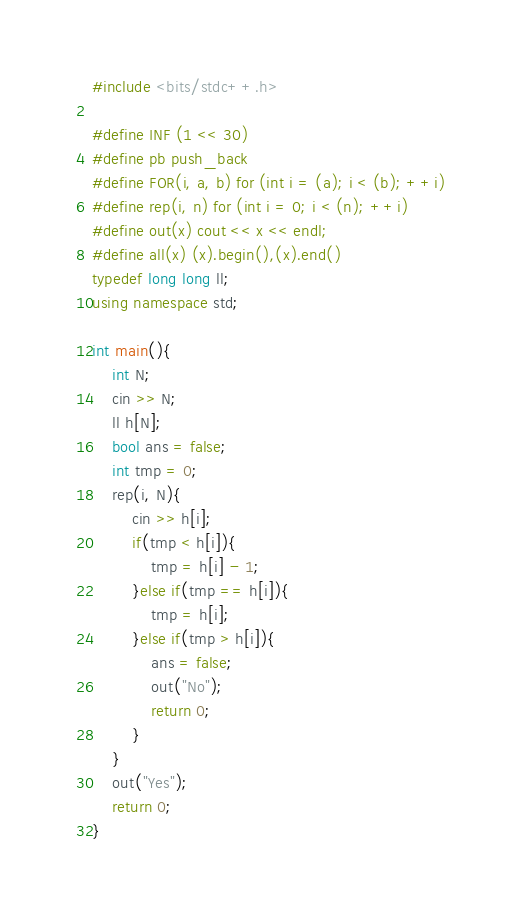<code> <loc_0><loc_0><loc_500><loc_500><_C++_>#include <bits/stdc++.h>

#define INF (1 << 30)
#define pb push_back
#define FOR(i, a, b) for (int i = (a); i < (b); ++i)
#define rep(i, n) for (int i = 0; i < (n); ++i)
#define out(x) cout << x << endl;
#define all(x) (x).begin(),(x).end()
typedef long long ll;
using namespace std;

int main(){
    int N;
    cin >> N;
    ll h[N];
    bool ans = false;
    int tmp = 0;
    rep(i, N){
        cin >> h[i];
        if(tmp < h[i]){
            tmp = h[i] - 1;
        }else if(tmp == h[i]){
            tmp = h[i];
        }else if(tmp > h[i]){
            ans = false;
            out("No");
            return 0;
        }
    }
    out("Yes");
    return 0;
}</code> 